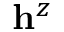<formula> <loc_0><loc_0><loc_500><loc_500>h ^ { z }</formula> 